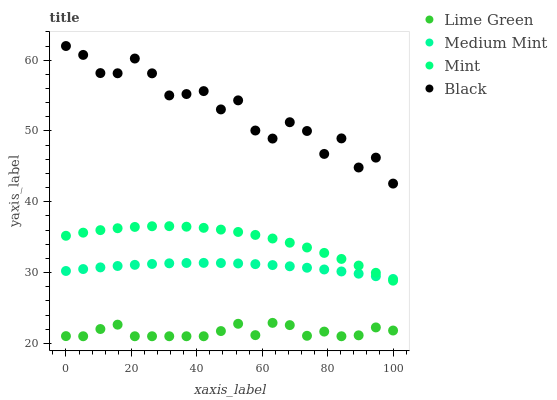Does Lime Green have the minimum area under the curve?
Answer yes or no. Yes. Does Black have the maximum area under the curve?
Answer yes or no. Yes. Does Mint have the minimum area under the curve?
Answer yes or no. No. Does Mint have the maximum area under the curve?
Answer yes or no. No. Is Medium Mint the smoothest?
Answer yes or no. Yes. Is Black the roughest?
Answer yes or no. Yes. Is Mint the smoothest?
Answer yes or no. No. Is Mint the roughest?
Answer yes or no. No. Does Lime Green have the lowest value?
Answer yes or no. Yes. Does Mint have the lowest value?
Answer yes or no. No. Does Black have the highest value?
Answer yes or no. Yes. Does Mint have the highest value?
Answer yes or no. No. Is Mint less than Black?
Answer yes or no. Yes. Is Black greater than Mint?
Answer yes or no. Yes. Does Mint intersect Medium Mint?
Answer yes or no. Yes. Is Mint less than Medium Mint?
Answer yes or no. No. Is Mint greater than Medium Mint?
Answer yes or no. No. Does Mint intersect Black?
Answer yes or no. No. 